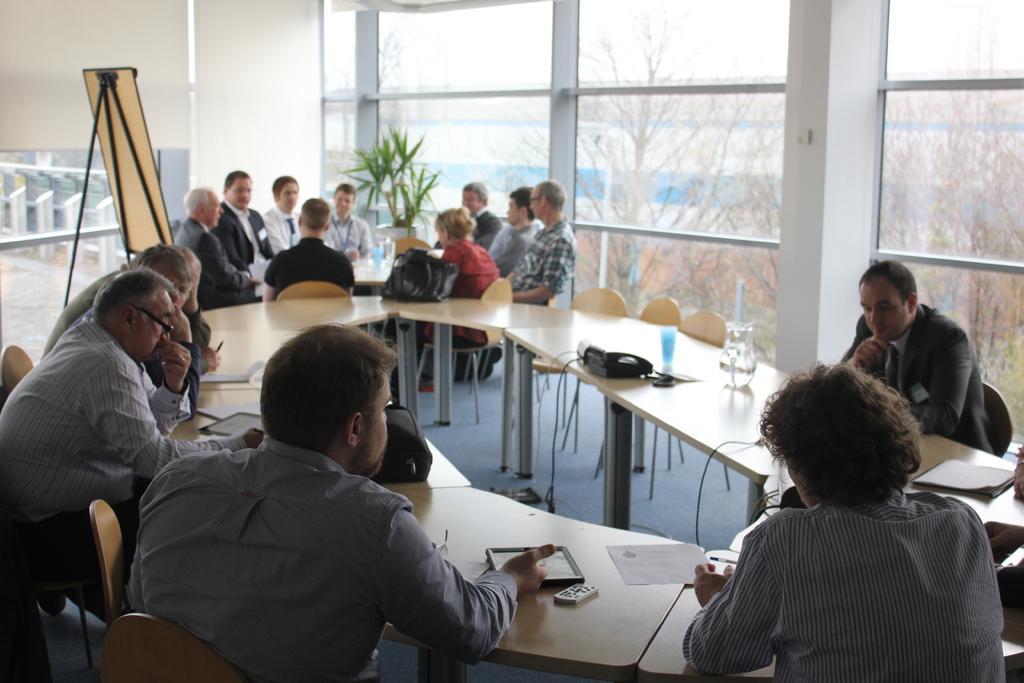In one or two sentences, can you explain what this image depicts? As we can see in the image there is a white color wall, windows and in the outside there are trees. There is a plant over here. there are few people sitting on chairs and there is a table. On table there is a remote, tablet, paper, a glass, mug and a telephone. 